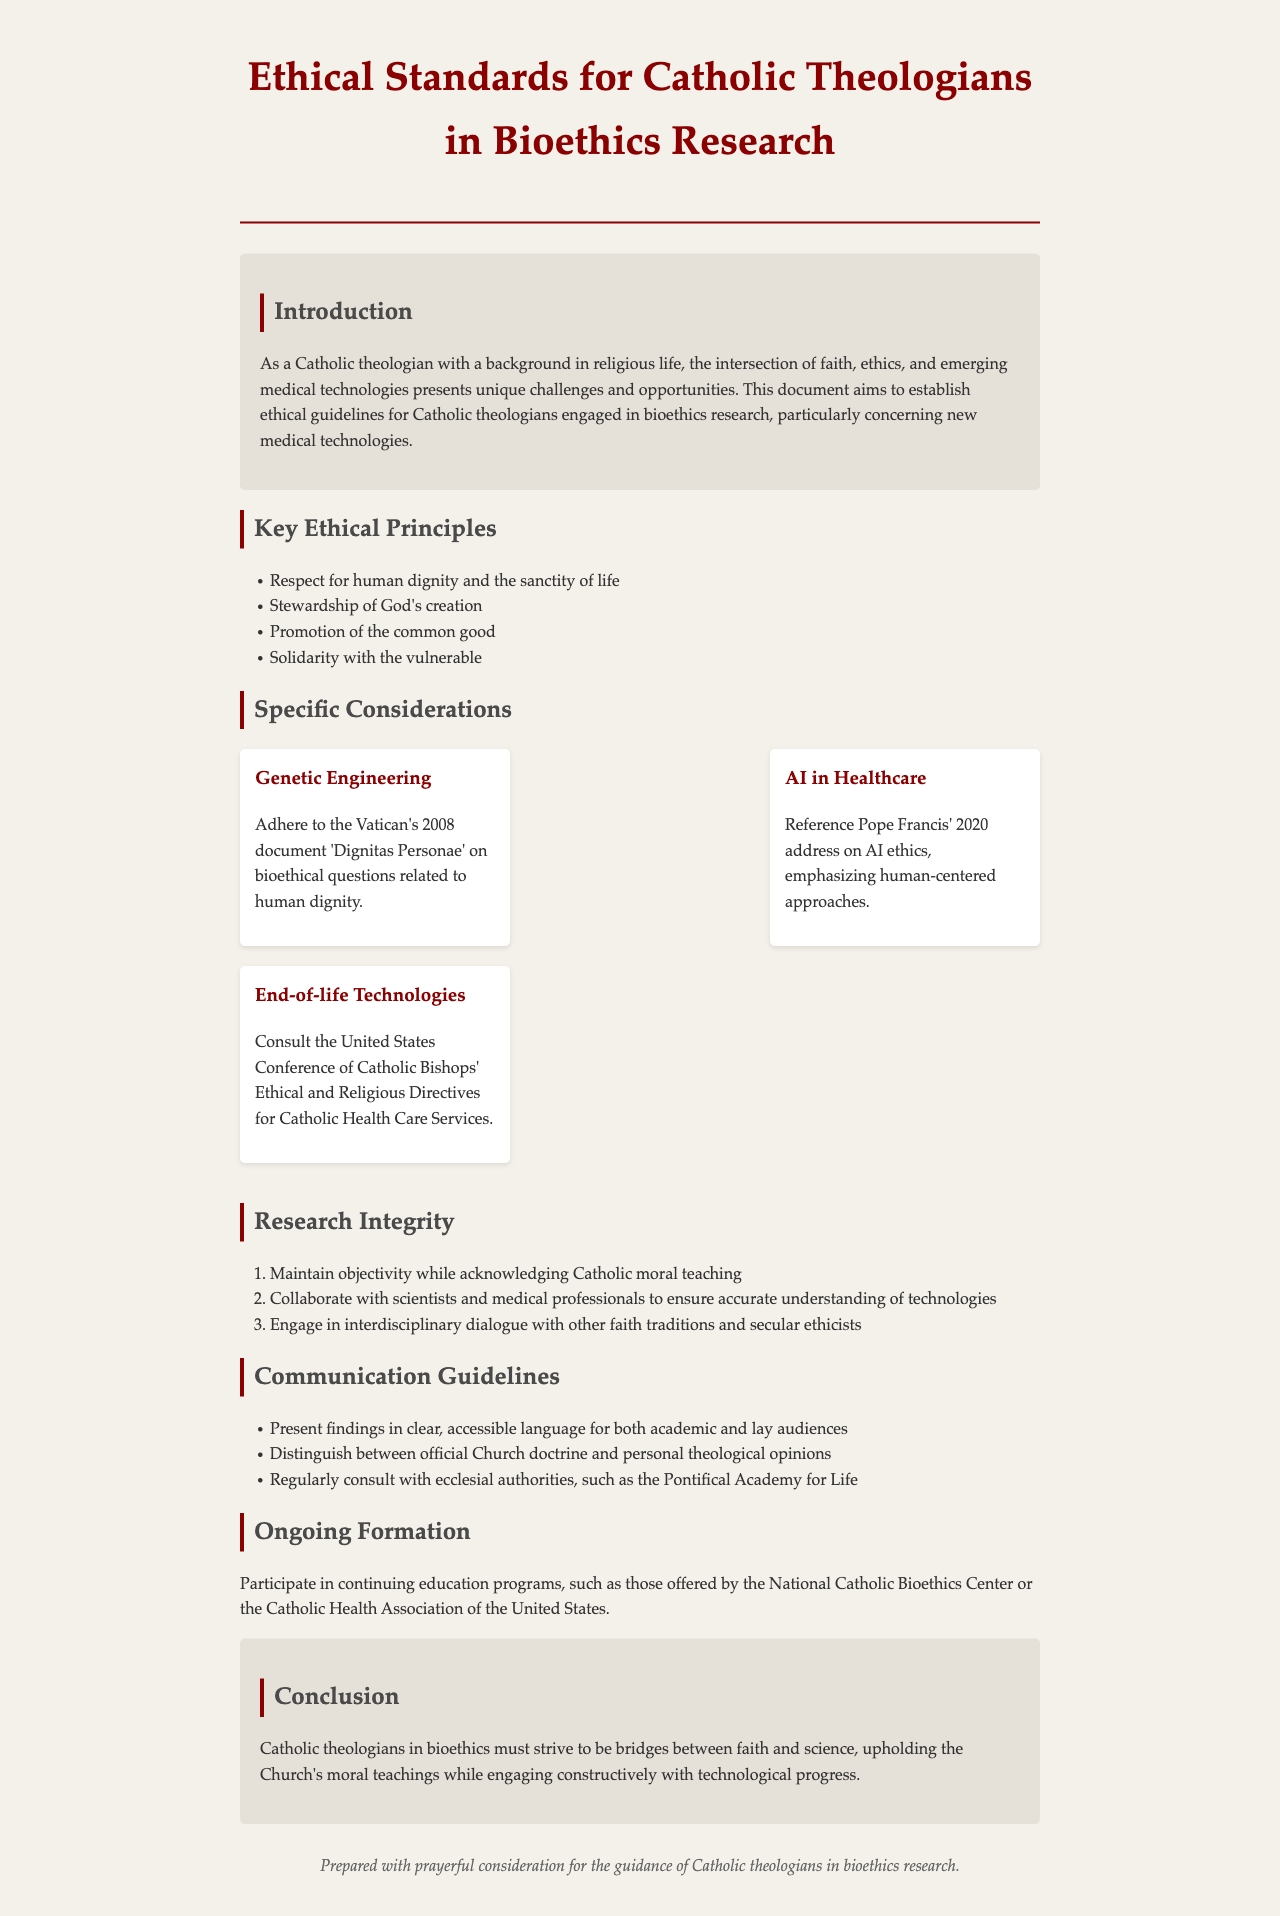What is the title of the document? The title is clearly stated in the header of the document.
Answer: Ethical Standards for Catholic Theologians in Bioethics Research What are the key ethical principles listed? The document provides a list of key ethical principles in a bullet format.
Answer: Respect for human dignity and the sanctity of life, Stewardship of God's creation, Promotion of the common good, Solidarity with the vulnerable What year was the Vatican's document 'Dignitas Personae' released? This document is mentioned in the context of genetic engineering guidelines.
Answer: 2008 Who is referenced regarding AI ethics? The document notes a significant address related to AI in healthcare.
Answer: Pope Francis What does the document suggest for end-of-life technologies? The document specifies a resource to consult in this area.
Answer: United States Conference of Catholic Bishops' Ethical and Religious Directives for Catholic Health Care Services How many points are listed under research integrity? This involves counting the items in the ordered list.
Answer: 3 What is highlighted as an important aspect of communication guidelines? The document mentions the importance of clarity in presenting findings.
Answer: Present findings in clear, accessible language for both academic and lay audiences What organizations are mentioned for ongoing formation? The document recommends specific organizations for continuous education.
Answer: National Catholic Bioethics Center, Catholic Health Association of the United States What is the concluding statement’s emphasis? The conclusion summarizes the role of theologians in bioethics.
Answer: Bridges between faith and science 